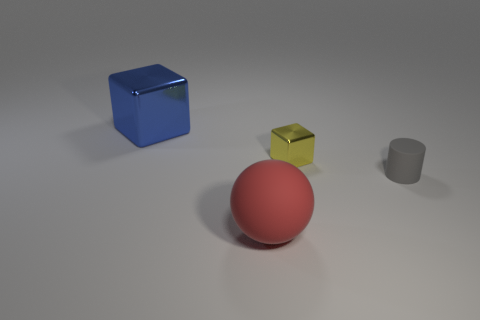Add 1 large red rubber spheres. How many objects exist? 5 Subtract all cylinders. How many objects are left? 3 Subtract 1 gray cylinders. How many objects are left? 3 Subtract all large blocks. Subtract all large red matte balls. How many objects are left? 2 Add 3 small yellow objects. How many small yellow objects are left? 4 Add 2 large metallic blocks. How many large metallic blocks exist? 3 